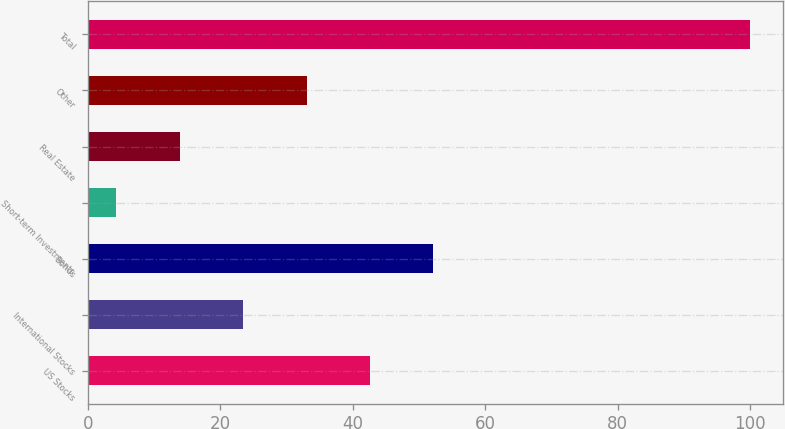<chart> <loc_0><loc_0><loc_500><loc_500><bar_chart><fcel>US Stocks<fcel>International Stocks<fcel>Bonds<fcel>Short-term Investments<fcel>Real Estate<fcel>Other<fcel>Total<nl><fcel>42.58<fcel>23.44<fcel>52.15<fcel>4.3<fcel>13.87<fcel>33.01<fcel>100<nl></chart> 